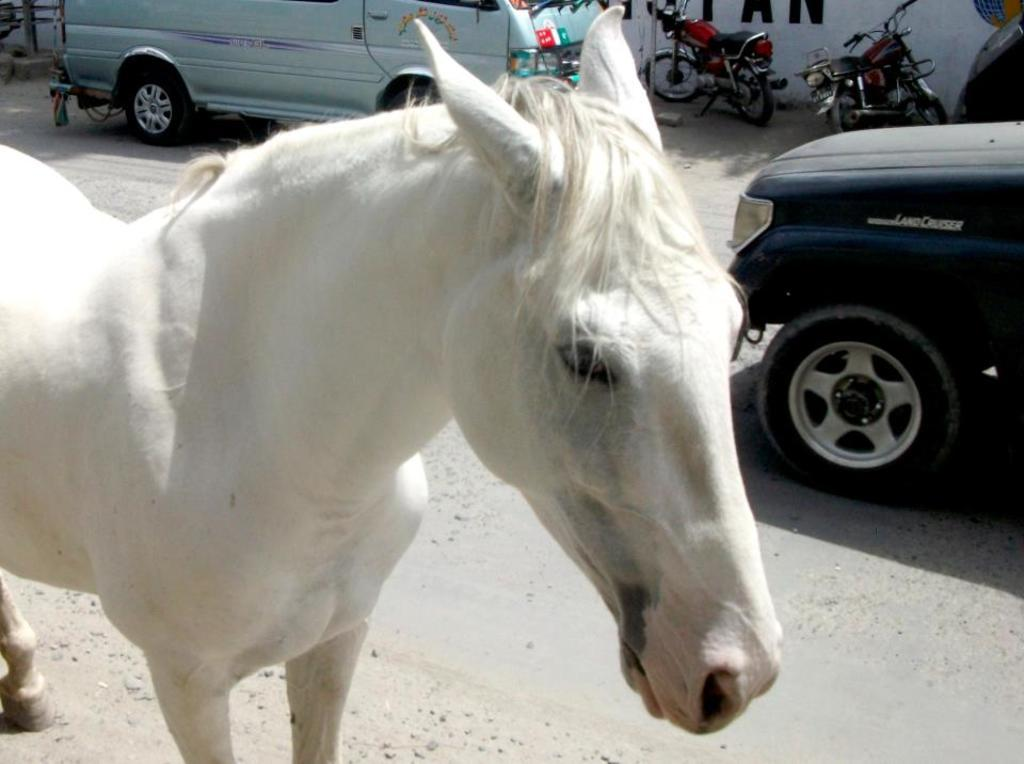What animal is present on the road in the image? There is a white horse on the road in the image. What else can be seen on the road besides the horse? Vehicles are visible in the image. What structure with text is present in the image? There is a wall with text on it in the image. What type of stone can be seen floating in the sky in the image? There is no stone floating in the sky in the image; the sky is not mentioned in the provided facts. 